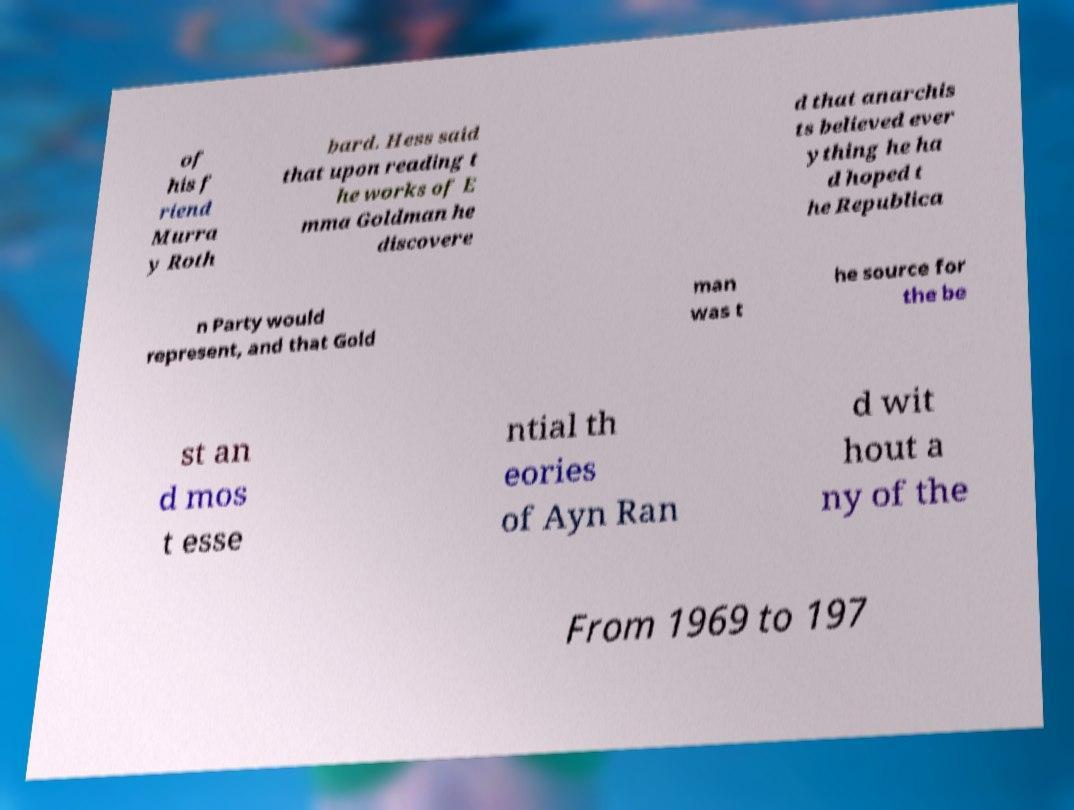Could you extract and type out the text from this image? of his f riend Murra y Roth bard. Hess said that upon reading t he works of E mma Goldman he discovere d that anarchis ts believed ever ything he ha d hoped t he Republica n Party would represent, and that Gold man was t he source for the be st an d mos t esse ntial th eories of Ayn Ran d wit hout a ny of the From 1969 to 197 